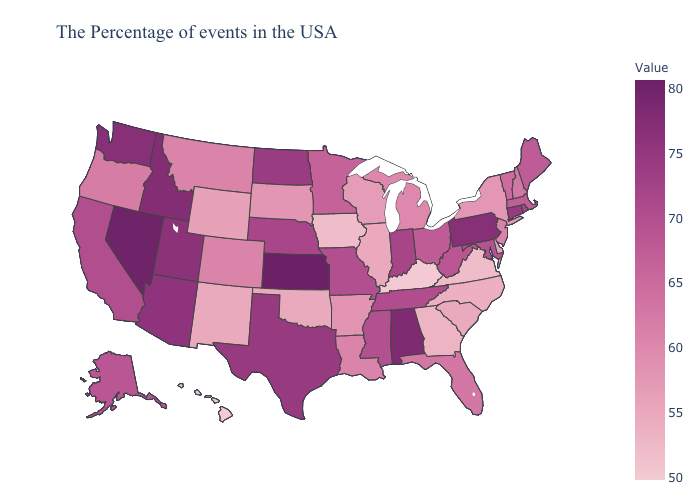Does Hawaii have the lowest value in the USA?
Quick response, please. Yes. Which states have the lowest value in the USA?
Write a very short answer. Hawaii. Which states have the highest value in the USA?
Give a very brief answer. Kansas. Does Missouri have the lowest value in the MidWest?
Answer briefly. No. Is the legend a continuous bar?
Concise answer only. Yes. 